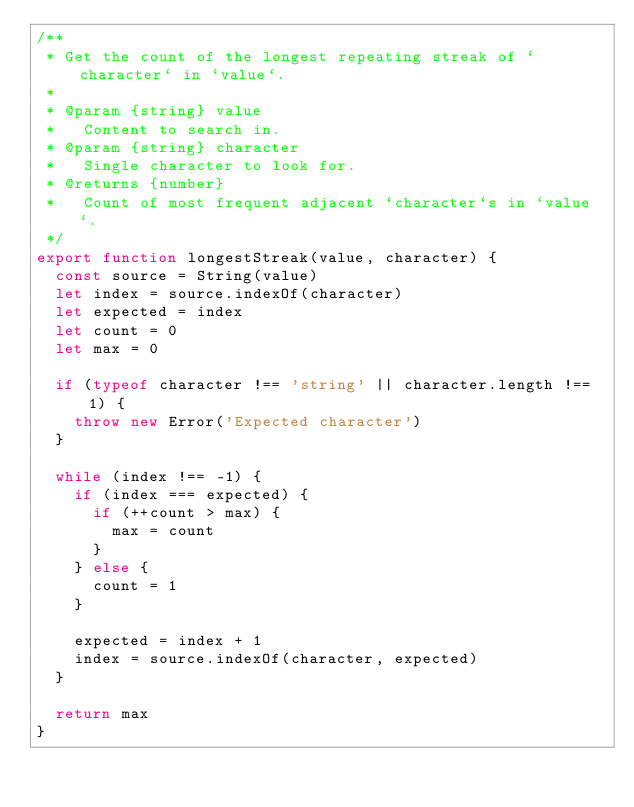<code> <loc_0><loc_0><loc_500><loc_500><_JavaScript_>/**
 * Get the count of the longest repeating streak of `character` in `value`.
 *
 * @param {string} value
 *   Content to search in.
 * @param {string} character
 *   Single character to look for.
 * @returns {number}
 *   Count of most frequent adjacent `character`s in `value`.
 */
export function longestStreak(value, character) {
  const source = String(value)
  let index = source.indexOf(character)
  let expected = index
  let count = 0
  let max = 0

  if (typeof character !== 'string' || character.length !== 1) {
    throw new Error('Expected character')
  }

  while (index !== -1) {
    if (index === expected) {
      if (++count > max) {
        max = count
      }
    } else {
      count = 1
    }

    expected = index + 1
    index = source.indexOf(character, expected)
  }

  return max
}
</code> 